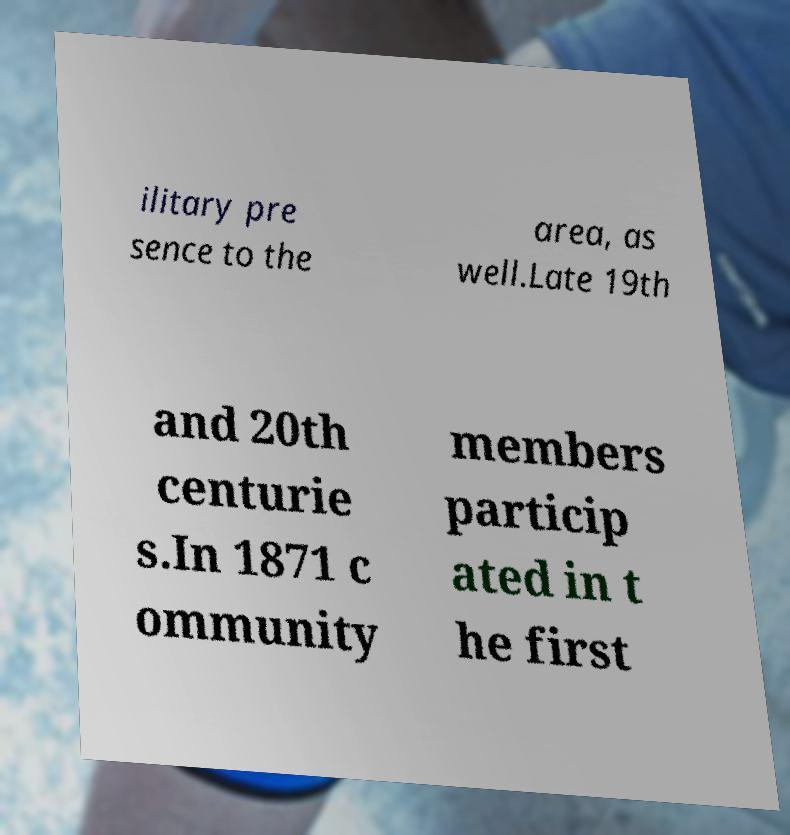Please identify and transcribe the text found in this image. ilitary pre sence to the area, as well.Late 19th and 20th centurie s.In 1871 c ommunity members particip ated in t he first 